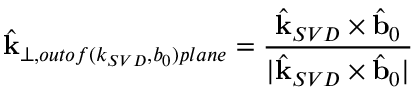Convert formula to latex. <formula><loc_0><loc_0><loc_500><loc_500>\hat { k } _ { \perp , o u t o f ( k _ { S V D } , b _ { 0 } ) p l a n e } = \frac { \hat { k } _ { S V D } \times \hat { b } _ { 0 } } { | \hat { k } _ { S V D } \times \hat { b } _ { 0 } | }</formula> 